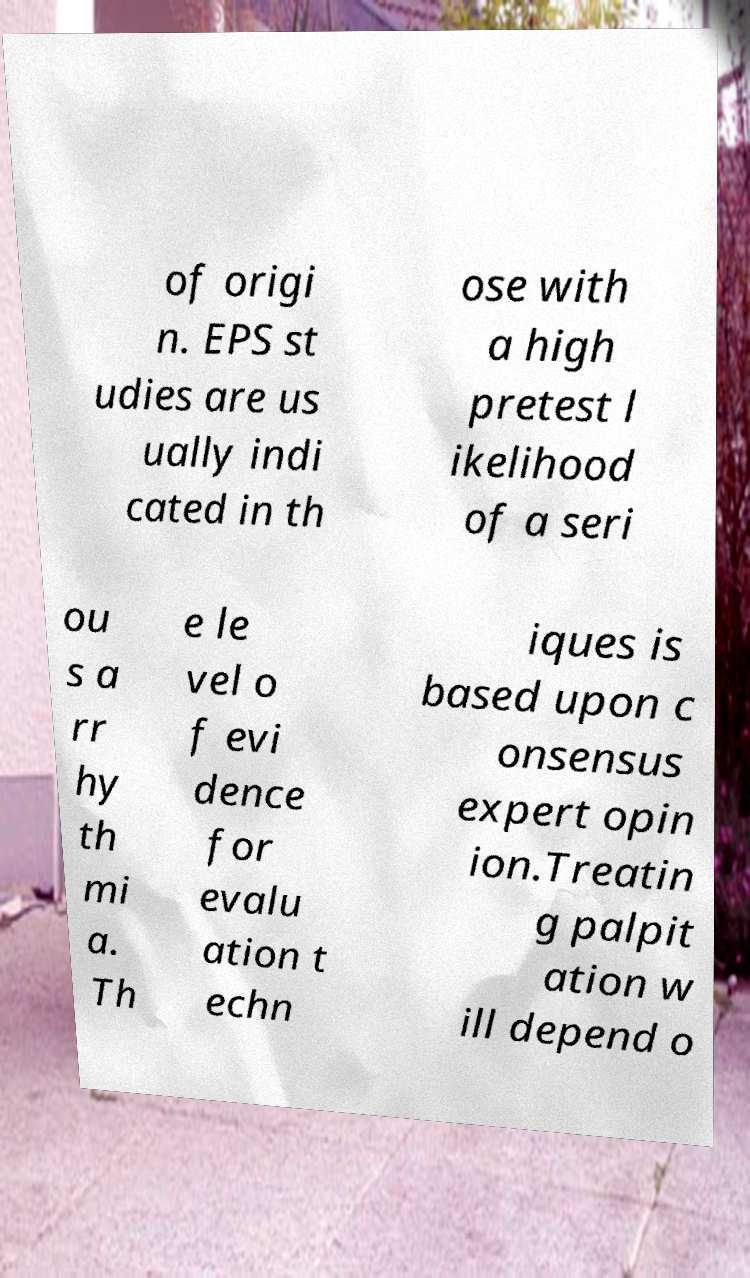For documentation purposes, I need the text within this image transcribed. Could you provide that? of origi n. EPS st udies are us ually indi cated in th ose with a high pretest l ikelihood of a seri ou s a rr hy th mi a. Th e le vel o f evi dence for evalu ation t echn iques is based upon c onsensus expert opin ion.Treatin g palpit ation w ill depend o 